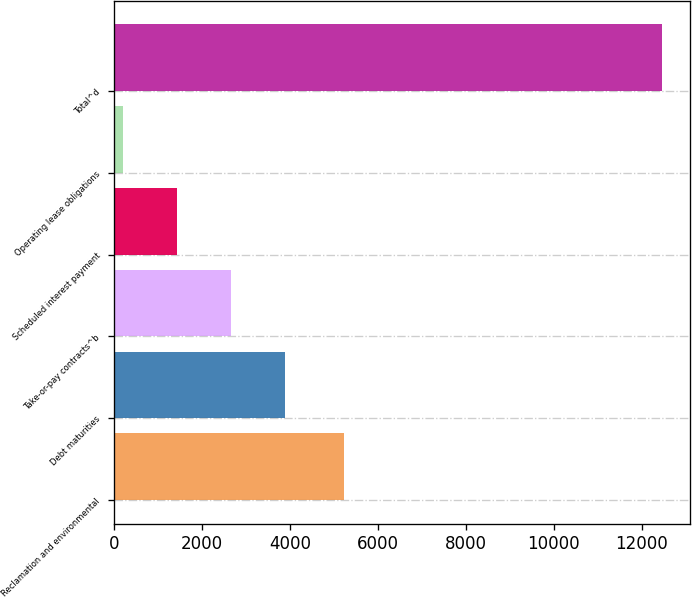<chart> <loc_0><loc_0><loc_500><loc_500><bar_chart><fcel>Reclamation and environmental<fcel>Debt maturities<fcel>Take-or-pay contracts^b<fcel>Scheduled interest payment<fcel>Operating lease obligations<fcel>Total^d<nl><fcel>5243<fcel>3882.7<fcel>2656.8<fcel>1430.9<fcel>205<fcel>12464<nl></chart> 